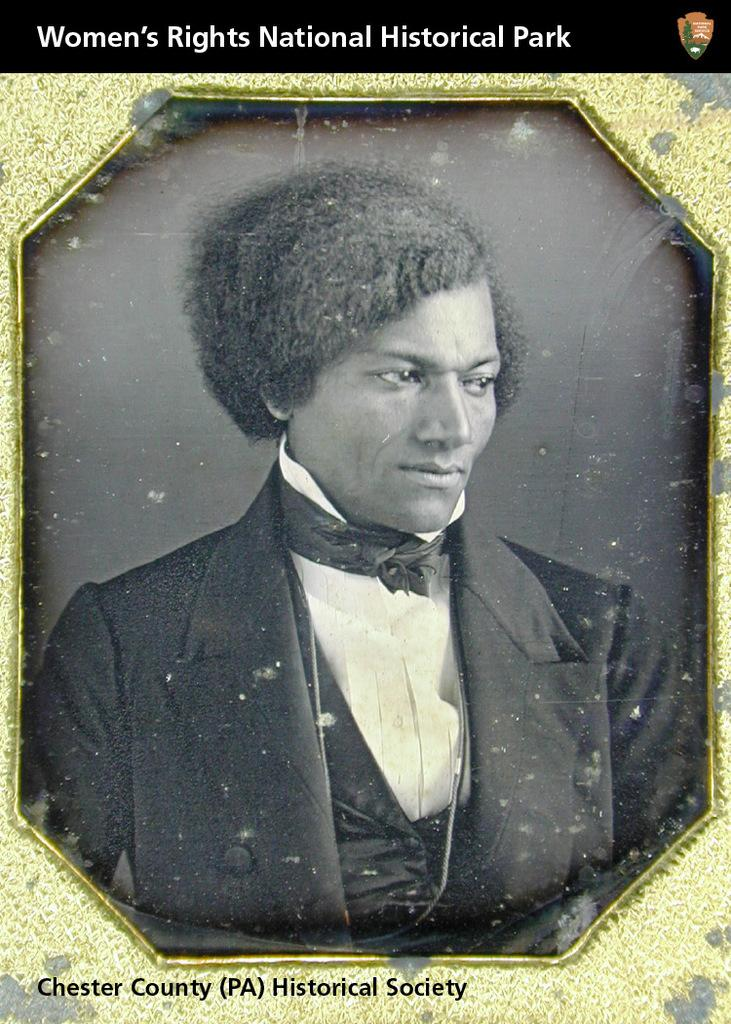<image>
Describe the image concisely. a women's rights label that is on a card 